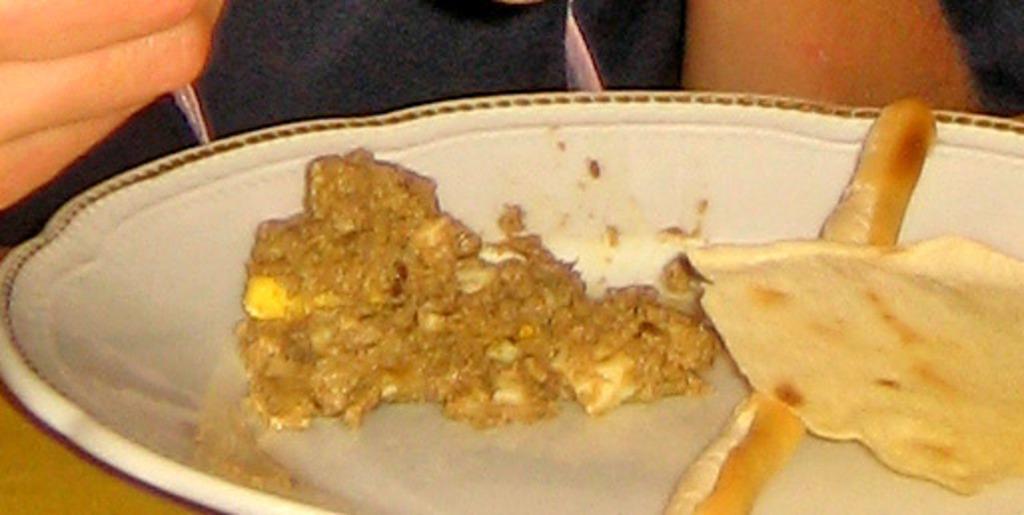How would you summarize this image in a sentence or two? In this picture we can see some food in a plate. This plate is on a wooden table. We can see a person. 